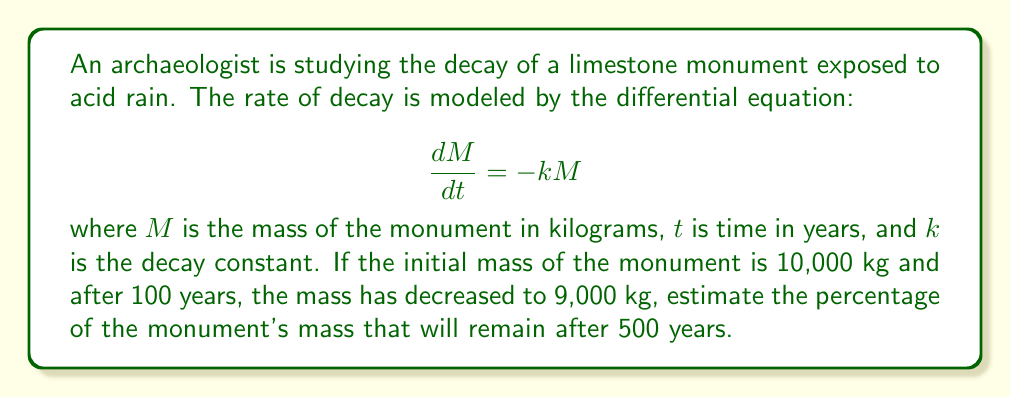Teach me how to tackle this problem. To solve this problem, we'll follow these steps:

1) First, we need to find the value of $k$. We can use the given information and the solution to the differential equation:

   $$M(t) = M_0e^{-kt}$$

   where $M_0$ is the initial mass.

2) Plugging in the known values:

   $$9000 = 10000e^{-k(100)}$$

3) Solving for $k$:

   $$\frac{9000}{10000} = e^{-100k}$$
   $$0.9 = e^{-100k}$$
   $$\ln(0.9) = -100k$$
   $$k = -\frac{\ln(0.9)}{100} \approx 0.001054$$

4) Now that we have $k$, we can use the same equation to find the mass after 500 years:

   $$M(500) = 10000e^{-0.001054(500)}$$

5) Calculating this:

   $$M(500) \approx 5934.85 \text{ kg}$$

6) To find the percentage remaining, we divide by the initial mass and multiply by 100:

   $$\text{Percentage remaining} = \frac{5934.85}{10000} \times 100 \approx 59.35\%$$

Therefore, after 500 years, approximately 59.35% of the monument's mass will remain.
Answer: 59.35% 